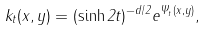<formula> <loc_0><loc_0><loc_500><loc_500>k _ { t } ( x , y ) = ( \sinh 2 t ) ^ { - d / 2 } e ^ { \Psi _ { t } ( x , y ) } ,</formula> 